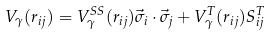<formula> <loc_0><loc_0><loc_500><loc_500>V _ { \gamma } ( r _ { i j } ) = V ^ { S S } _ { \gamma } ( r _ { i j } ) \vec { \sigma } _ { i } \cdot \vec { \sigma } _ { j } + V ^ { T } _ { \gamma } ( r _ { i j } ) S ^ { T } _ { i j }</formula> 